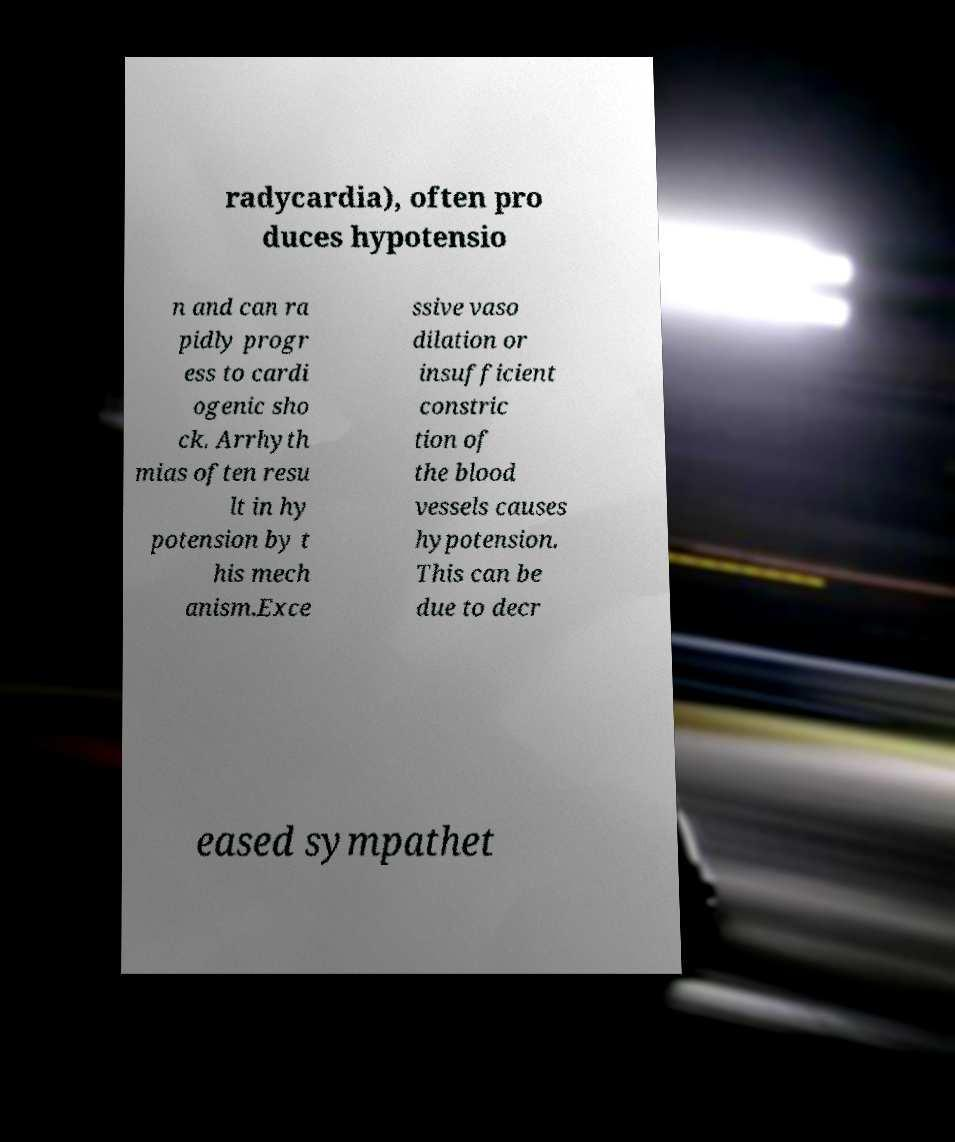Please identify and transcribe the text found in this image. radycardia), often pro duces hypotensio n and can ra pidly progr ess to cardi ogenic sho ck. Arrhyth mias often resu lt in hy potension by t his mech anism.Exce ssive vaso dilation or insufficient constric tion of the blood vessels causes hypotension. This can be due to decr eased sympathet 